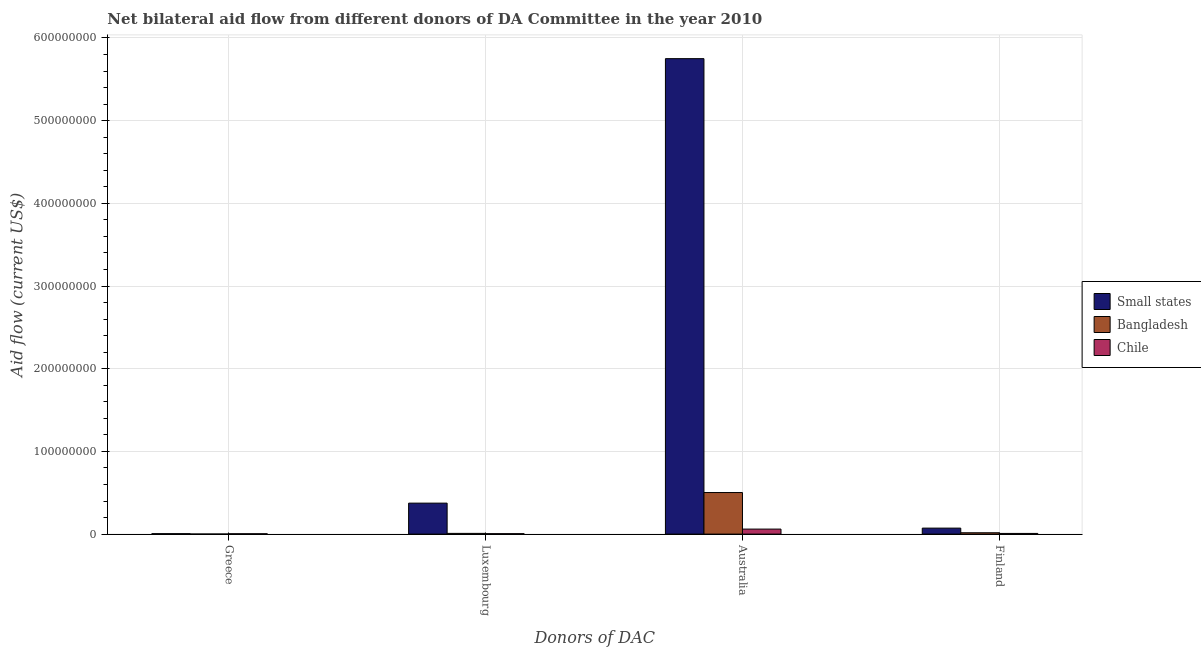How many bars are there on the 2nd tick from the left?
Your response must be concise. 3. What is the amount of aid given by australia in Chile?
Provide a short and direct response. 6.06e+06. Across all countries, what is the maximum amount of aid given by australia?
Your response must be concise. 5.75e+08. Across all countries, what is the minimum amount of aid given by luxembourg?
Your answer should be very brief. 5.20e+05. In which country was the amount of aid given by luxembourg maximum?
Provide a succinct answer. Small states. In which country was the amount of aid given by finland minimum?
Your answer should be compact. Chile. What is the total amount of aid given by greece in the graph?
Offer a very short reply. 1.01e+06. What is the difference between the amount of aid given by finland in Small states and that in Bangladesh?
Your response must be concise. 5.60e+06. What is the difference between the amount of aid given by luxembourg in Bangladesh and the amount of aid given by greece in Small states?
Your answer should be very brief. 3.50e+05. What is the average amount of aid given by luxembourg per country?
Make the answer very short. 1.30e+07. What is the difference between the amount of aid given by luxembourg and amount of aid given by australia in Bangladesh?
Keep it short and to the point. -4.94e+07. What is the ratio of the amount of aid given by finland in Small states to that in Chile?
Your answer should be compact. 8.82. Is the amount of aid given by finland in Chile less than that in Bangladesh?
Offer a very short reply. Yes. What is the difference between the highest and the second highest amount of aid given by australia?
Give a very brief answer. 5.25e+08. What is the difference between the highest and the lowest amount of aid given by australia?
Make the answer very short. 5.69e+08. In how many countries, is the amount of aid given by australia greater than the average amount of aid given by australia taken over all countries?
Your answer should be compact. 1. Is the sum of the amount of aid given by finland in Chile and Bangladesh greater than the maximum amount of aid given by greece across all countries?
Your answer should be compact. Yes. Is it the case that in every country, the sum of the amount of aid given by australia and amount of aid given by finland is greater than the sum of amount of aid given by luxembourg and amount of aid given by greece?
Your answer should be very brief. Yes. What does the 2nd bar from the left in Australia represents?
Ensure brevity in your answer.  Bangladesh. Is it the case that in every country, the sum of the amount of aid given by greece and amount of aid given by luxembourg is greater than the amount of aid given by australia?
Your answer should be very brief. No. Are all the bars in the graph horizontal?
Offer a terse response. No. How many countries are there in the graph?
Keep it short and to the point. 3. Are the values on the major ticks of Y-axis written in scientific E-notation?
Your answer should be compact. No. Does the graph contain any zero values?
Offer a terse response. No. Does the graph contain grids?
Keep it short and to the point. Yes. Where does the legend appear in the graph?
Your answer should be compact. Center right. How many legend labels are there?
Give a very brief answer. 3. What is the title of the graph?
Ensure brevity in your answer.  Net bilateral aid flow from different donors of DA Committee in the year 2010. Does "Yemen, Rep." appear as one of the legend labels in the graph?
Offer a very short reply. No. What is the label or title of the X-axis?
Ensure brevity in your answer.  Donors of DAC. What is the label or title of the Y-axis?
Provide a succinct answer. Aid flow (current US$). What is the Aid flow (current US$) of Small states in Greece?
Provide a short and direct response. 5.20e+05. What is the Aid flow (current US$) in Bangladesh in Greece?
Your response must be concise. 8.00e+04. What is the Aid flow (current US$) of Chile in Greece?
Make the answer very short. 4.10e+05. What is the Aid flow (current US$) in Small states in Luxembourg?
Provide a short and direct response. 3.75e+07. What is the Aid flow (current US$) of Bangladesh in Luxembourg?
Your answer should be very brief. 8.70e+05. What is the Aid flow (current US$) in Chile in Luxembourg?
Offer a terse response. 5.20e+05. What is the Aid flow (current US$) in Small states in Australia?
Keep it short and to the point. 5.75e+08. What is the Aid flow (current US$) in Bangladesh in Australia?
Make the answer very short. 5.03e+07. What is the Aid flow (current US$) of Chile in Australia?
Provide a short and direct response. 6.06e+06. What is the Aid flow (current US$) of Small states in Finland?
Provide a succinct answer. 7.23e+06. What is the Aid flow (current US$) of Bangladesh in Finland?
Your response must be concise. 1.63e+06. What is the Aid flow (current US$) of Chile in Finland?
Your answer should be compact. 8.20e+05. Across all Donors of DAC, what is the maximum Aid flow (current US$) of Small states?
Ensure brevity in your answer.  5.75e+08. Across all Donors of DAC, what is the maximum Aid flow (current US$) of Bangladesh?
Give a very brief answer. 5.03e+07. Across all Donors of DAC, what is the maximum Aid flow (current US$) in Chile?
Offer a terse response. 6.06e+06. Across all Donors of DAC, what is the minimum Aid flow (current US$) in Small states?
Your response must be concise. 5.20e+05. What is the total Aid flow (current US$) in Small states in the graph?
Make the answer very short. 6.20e+08. What is the total Aid flow (current US$) of Bangladesh in the graph?
Give a very brief answer. 5.28e+07. What is the total Aid flow (current US$) of Chile in the graph?
Offer a terse response. 7.81e+06. What is the difference between the Aid flow (current US$) in Small states in Greece and that in Luxembourg?
Offer a terse response. -3.69e+07. What is the difference between the Aid flow (current US$) of Bangladesh in Greece and that in Luxembourg?
Offer a very short reply. -7.90e+05. What is the difference between the Aid flow (current US$) in Small states in Greece and that in Australia?
Give a very brief answer. -5.74e+08. What is the difference between the Aid flow (current US$) of Bangladesh in Greece and that in Australia?
Your answer should be very brief. -5.02e+07. What is the difference between the Aid flow (current US$) in Chile in Greece and that in Australia?
Offer a very short reply. -5.65e+06. What is the difference between the Aid flow (current US$) in Small states in Greece and that in Finland?
Offer a very short reply. -6.71e+06. What is the difference between the Aid flow (current US$) in Bangladesh in Greece and that in Finland?
Provide a succinct answer. -1.55e+06. What is the difference between the Aid flow (current US$) in Chile in Greece and that in Finland?
Your response must be concise. -4.10e+05. What is the difference between the Aid flow (current US$) in Small states in Luxembourg and that in Australia?
Your answer should be very brief. -5.38e+08. What is the difference between the Aid flow (current US$) in Bangladesh in Luxembourg and that in Australia?
Provide a short and direct response. -4.94e+07. What is the difference between the Aid flow (current US$) of Chile in Luxembourg and that in Australia?
Your response must be concise. -5.54e+06. What is the difference between the Aid flow (current US$) of Small states in Luxembourg and that in Finland?
Your answer should be very brief. 3.02e+07. What is the difference between the Aid flow (current US$) in Bangladesh in Luxembourg and that in Finland?
Give a very brief answer. -7.60e+05. What is the difference between the Aid flow (current US$) in Chile in Luxembourg and that in Finland?
Your answer should be compact. -3.00e+05. What is the difference between the Aid flow (current US$) in Small states in Australia and that in Finland?
Keep it short and to the point. 5.68e+08. What is the difference between the Aid flow (current US$) in Bangladesh in Australia and that in Finland?
Ensure brevity in your answer.  4.86e+07. What is the difference between the Aid flow (current US$) of Chile in Australia and that in Finland?
Offer a very short reply. 5.24e+06. What is the difference between the Aid flow (current US$) in Small states in Greece and the Aid flow (current US$) in Bangladesh in Luxembourg?
Your answer should be very brief. -3.50e+05. What is the difference between the Aid flow (current US$) of Bangladesh in Greece and the Aid flow (current US$) of Chile in Luxembourg?
Your answer should be very brief. -4.40e+05. What is the difference between the Aid flow (current US$) in Small states in Greece and the Aid flow (current US$) in Bangladesh in Australia?
Keep it short and to the point. -4.98e+07. What is the difference between the Aid flow (current US$) of Small states in Greece and the Aid flow (current US$) of Chile in Australia?
Your answer should be compact. -5.54e+06. What is the difference between the Aid flow (current US$) in Bangladesh in Greece and the Aid flow (current US$) in Chile in Australia?
Provide a succinct answer. -5.98e+06. What is the difference between the Aid flow (current US$) of Small states in Greece and the Aid flow (current US$) of Bangladesh in Finland?
Offer a terse response. -1.11e+06. What is the difference between the Aid flow (current US$) in Small states in Greece and the Aid flow (current US$) in Chile in Finland?
Keep it short and to the point. -3.00e+05. What is the difference between the Aid flow (current US$) in Bangladesh in Greece and the Aid flow (current US$) in Chile in Finland?
Keep it short and to the point. -7.40e+05. What is the difference between the Aid flow (current US$) of Small states in Luxembourg and the Aid flow (current US$) of Bangladesh in Australia?
Offer a terse response. -1.28e+07. What is the difference between the Aid flow (current US$) in Small states in Luxembourg and the Aid flow (current US$) in Chile in Australia?
Offer a terse response. 3.14e+07. What is the difference between the Aid flow (current US$) in Bangladesh in Luxembourg and the Aid flow (current US$) in Chile in Australia?
Keep it short and to the point. -5.19e+06. What is the difference between the Aid flow (current US$) of Small states in Luxembourg and the Aid flow (current US$) of Bangladesh in Finland?
Give a very brief answer. 3.58e+07. What is the difference between the Aid flow (current US$) of Small states in Luxembourg and the Aid flow (current US$) of Chile in Finland?
Offer a very short reply. 3.66e+07. What is the difference between the Aid flow (current US$) in Small states in Australia and the Aid flow (current US$) in Bangladesh in Finland?
Give a very brief answer. 5.73e+08. What is the difference between the Aid flow (current US$) in Small states in Australia and the Aid flow (current US$) in Chile in Finland?
Keep it short and to the point. 5.74e+08. What is the difference between the Aid flow (current US$) in Bangladesh in Australia and the Aid flow (current US$) in Chile in Finland?
Your answer should be compact. 4.94e+07. What is the average Aid flow (current US$) in Small states per Donors of DAC?
Provide a short and direct response. 1.55e+08. What is the average Aid flow (current US$) of Bangladesh per Donors of DAC?
Offer a very short reply. 1.32e+07. What is the average Aid flow (current US$) of Chile per Donors of DAC?
Provide a short and direct response. 1.95e+06. What is the difference between the Aid flow (current US$) in Small states and Aid flow (current US$) in Bangladesh in Greece?
Your answer should be very brief. 4.40e+05. What is the difference between the Aid flow (current US$) of Small states and Aid flow (current US$) of Chile in Greece?
Keep it short and to the point. 1.10e+05. What is the difference between the Aid flow (current US$) of Bangladesh and Aid flow (current US$) of Chile in Greece?
Keep it short and to the point. -3.30e+05. What is the difference between the Aid flow (current US$) in Small states and Aid flow (current US$) in Bangladesh in Luxembourg?
Ensure brevity in your answer.  3.66e+07. What is the difference between the Aid flow (current US$) of Small states and Aid flow (current US$) of Chile in Luxembourg?
Provide a succinct answer. 3.69e+07. What is the difference between the Aid flow (current US$) of Small states and Aid flow (current US$) of Bangladesh in Australia?
Provide a succinct answer. 5.25e+08. What is the difference between the Aid flow (current US$) of Small states and Aid flow (current US$) of Chile in Australia?
Your response must be concise. 5.69e+08. What is the difference between the Aid flow (current US$) of Bangladesh and Aid flow (current US$) of Chile in Australia?
Your response must be concise. 4.42e+07. What is the difference between the Aid flow (current US$) in Small states and Aid flow (current US$) in Bangladesh in Finland?
Offer a terse response. 5.60e+06. What is the difference between the Aid flow (current US$) in Small states and Aid flow (current US$) in Chile in Finland?
Provide a succinct answer. 6.41e+06. What is the difference between the Aid flow (current US$) in Bangladesh and Aid flow (current US$) in Chile in Finland?
Provide a short and direct response. 8.10e+05. What is the ratio of the Aid flow (current US$) in Small states in Greece to that in Luxembourg?
Keep it short and to the point. 0.01. What is the ratio of the Aid flow (current US$) in Bangladesh in Greece to that in Luxembourg?
Offer a terse response. 0.09. What is the ratio of the Aid flow (current US$) of Chile in Greece to that in Luxembourg?
Your response must be concise. 0.79. What is the ratio of the Aid flow (current US$) in Small states in Greece to that in Australia?
Your answer should be compact. 0. What is the ratio of the Aid flow (current US$) of Bangladesh in Greece to that in Australia?
Your response must be concise. 0. What is the ratio of the Aid flow (current US$) in Chile in Greece to that in Australia?
Make the answer very short. 0.07. What is the ratio of the Aid flow (current US$) in Small states in Greece to that in Finland?
Your response must be concise. 0.07. What is the ratio of the Aid flow (current US$) in Bangladesh in Greece to that in Finland?
Offer a very short reply. 0.05. What is the ratio of the Aid flow (current US$) in Small states in Luxembourg to that in Australia?
Provide a succinct answer. 0.07. What is the ratio of the Aid flow (current US$) in Bangladesh in Luxembourg to that in Australia?
Your answer should be very brief. 0.02. What is the ratio of the Aid flow (current US$) of Chile in Luxembourg to that in Australia?
Ensure brevity in your answer.  0.09. What is the ratio of the Aid flow (current US$) in Small states in Luxembourg to that in Finland?
Provide a succinct answer. 5.18. What is the ratio of the Aid flow (current US$) of Bangladesh in Luxembourg to that in Finland?
Offer a terse response. 0.53. What is the ratio of the Aid flow (current US$) of Chile in Luxembourg to that in Finland?
Make the answer very short. 0.63. What is the ratio of the Aid flow (current US$) in Small states in Australia to that in Finland?
Provide a succinct answer. 79.53. What is the ratio of the Aid flow (current US$) of Bangladesh in Australia to that in Finland?
Your answer should be very brief. 30.84. What is the ratio of the Aid flow (current US$) in Chile in Australia to that in Finland?
Make the answer very short. 7.39. What is the difference between the highest and the second highest Aid flow (current US$) of Small states?
Your answer should be compact. 5.38e+08. What is the difference between the highest and the second highest Aid flow (current US$) of Bangladesh?
Keep it short and to the point. 4.86e+07. What is the difference between the highest and the second highest Aid flow (current US$) in Chile?
Make the answer very short. 5.24e+06. What is the difference between the highest and the lowest Aid flow (current US$) in Small states?
Give a very brief answer. 5.74e+08. What is the difference between the highest and the lowest Aid flow (current US$) of Bangladesh?
Ensure brevity in your answer.  5.02e+07. What is the difference between the highest and the lowest Aid flow (current US$) of Chile?
Give a very brief answer. 5.65e+06. 